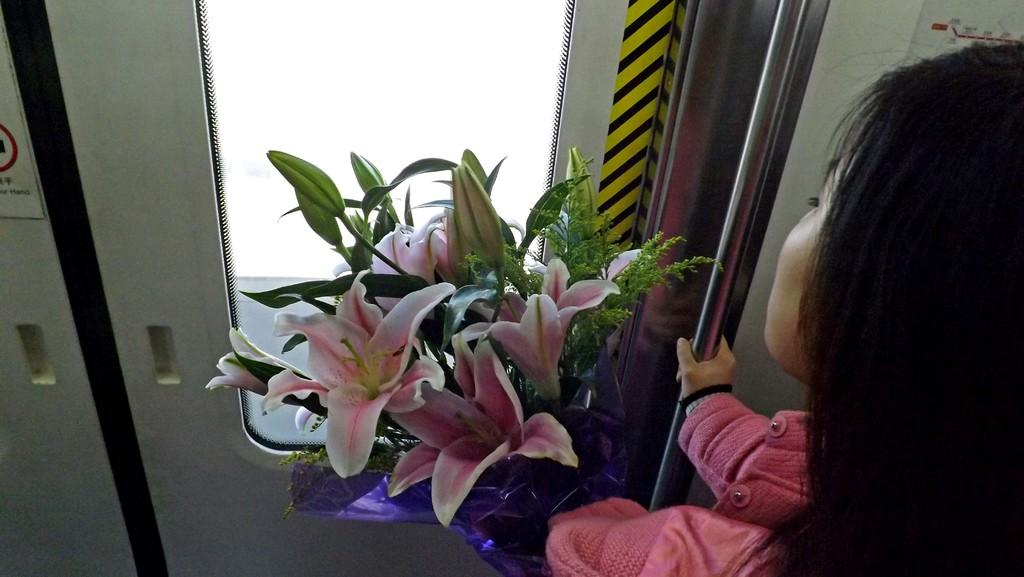Who is present in the image? There is a woman in the image. What is the woman holding? The woman is holding a flower bouquet. What can be seen in the background of the image? There is a pole, a door, a poster, and a glass in the background of the image. What type of insurance policy is advertised on the poster in the image? There is no insurance policy advertised on the poster in the image; it is a flower bouquet that the woman is holding. How much wealth is visible in the image? There is no indication of wealth in the image; it features a woman holding a flower bouquet and various background elements. 